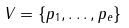Convert formula to latex. <formula><loc_0><loc_0><loc_500><loc_500>V = \{ p _ { 1 } , \dots , p _ { e } \}</formula> 